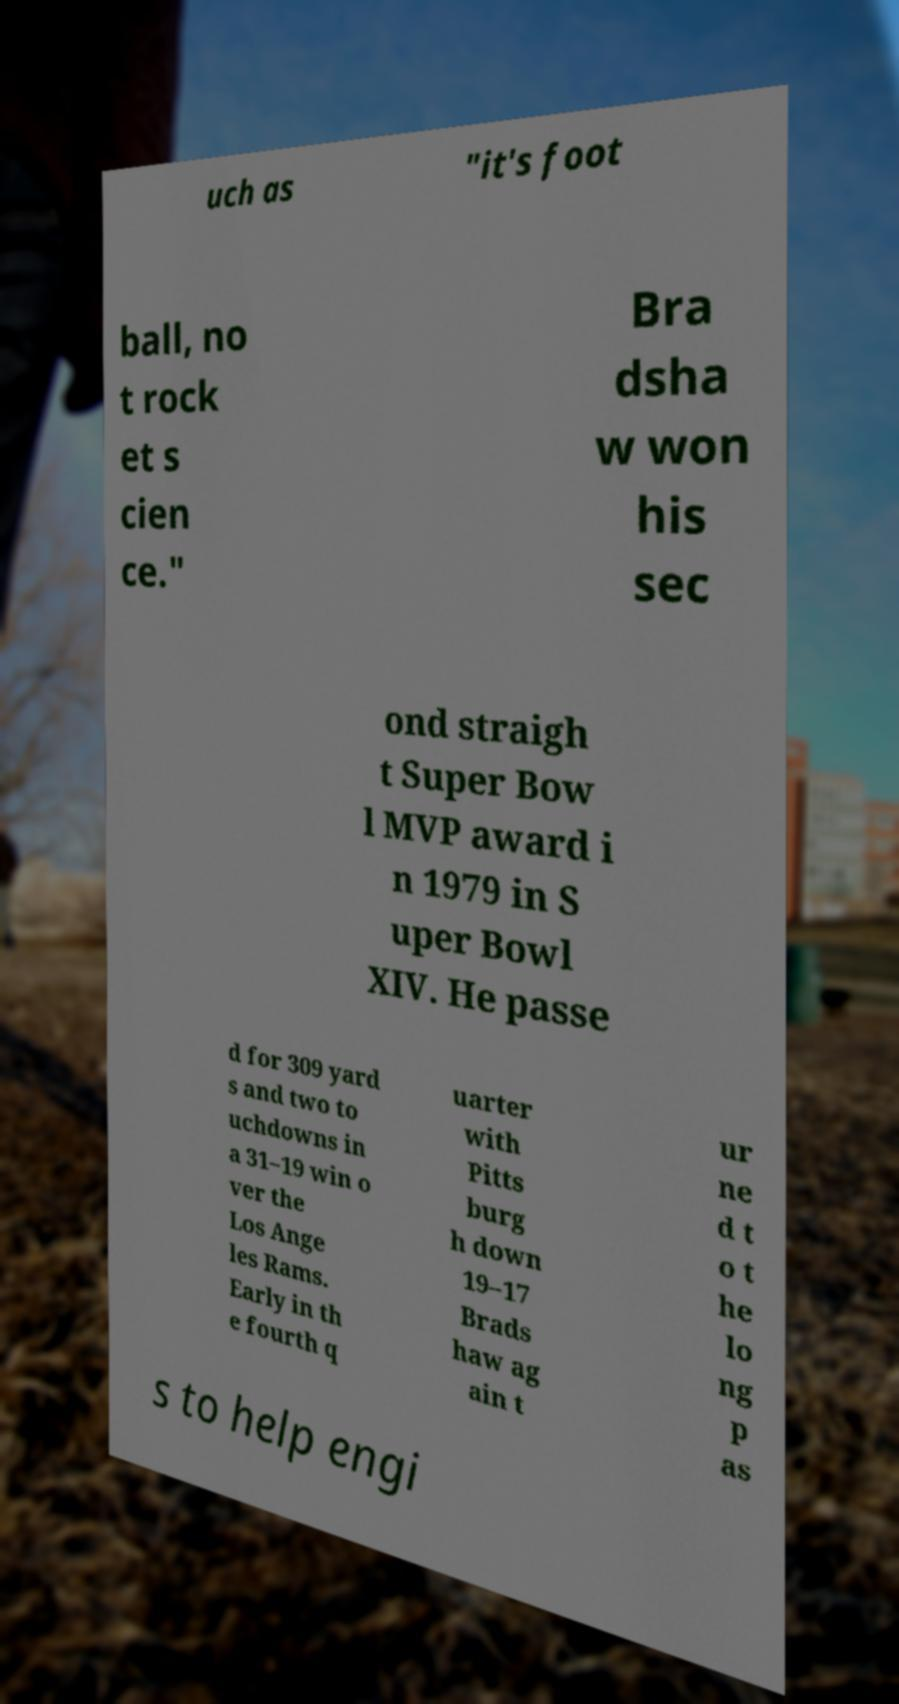There's text embedded in this image that I need extracted. Can you transcribe it verbatim? uch as "it's foot ball, no t rock et s cien ce." Bra dsha w won his sec ond straigh t Super Bow l MVP award i n 1979 in S uper Bowl XIV. He passe d for 309 yard s and two to uchdowns in a 31–19 win o ver the Los Ange les Rams. Early in th e fourth q uarter with Pitts burg h down 19–17 Brads haw ag ain t ur ne d t o t he lo ng p as s to help engi 